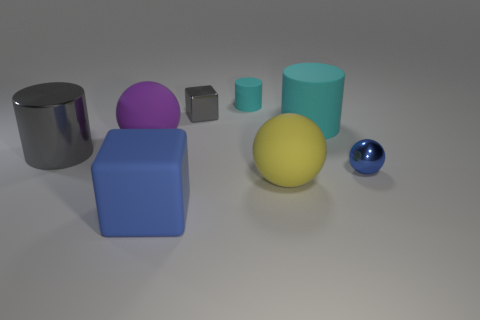Subtract all blue cylinders. Subtract all blue blocks. How many cylinders are left? 3 Add 1 large gray shiny cylinders. How many objects exist? 9 Subtract all balls. How many objects are left? 5 Add 4 purple rubber things. How many purple rubber things exist? 5 Subtract 0 red cubes. How many objects are left? 8 Subtract all blue objects. Subtract all large rubber things. How many objects are left? 2 Add 5 large blue cubes. How many large blue cubes are left? 6 